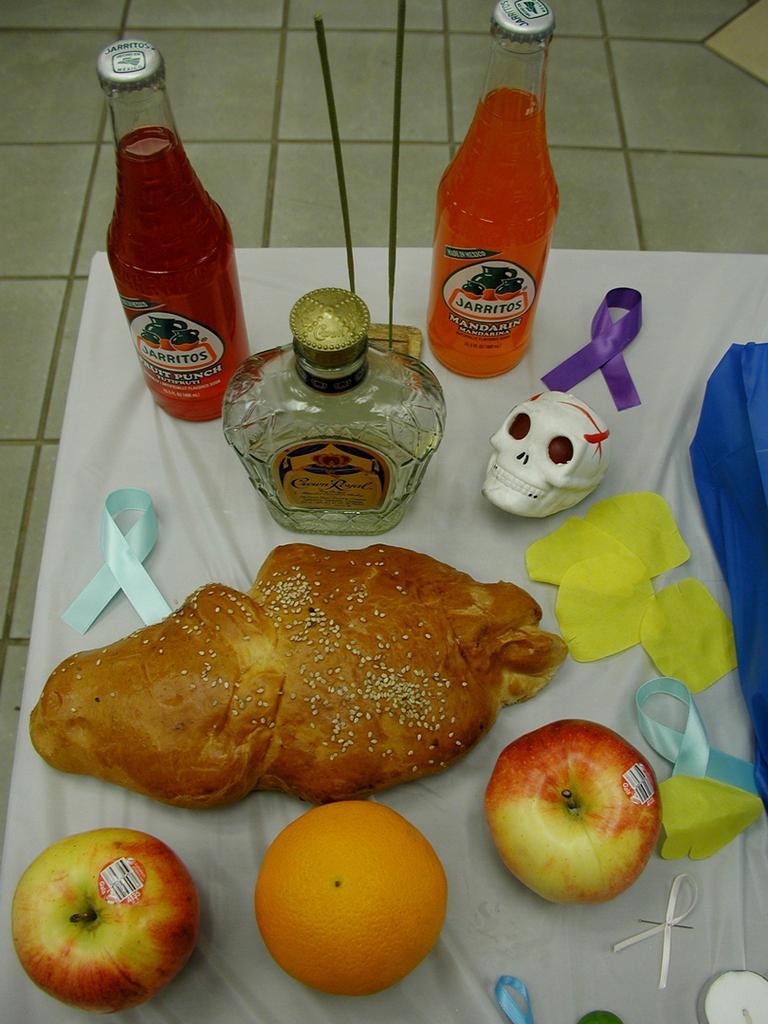How would you summarize this image in a sentence or two? In this picture we can see a bun with sesame seeds, apple , orange, ribbons , a skull and few bottles on a white cloth. 